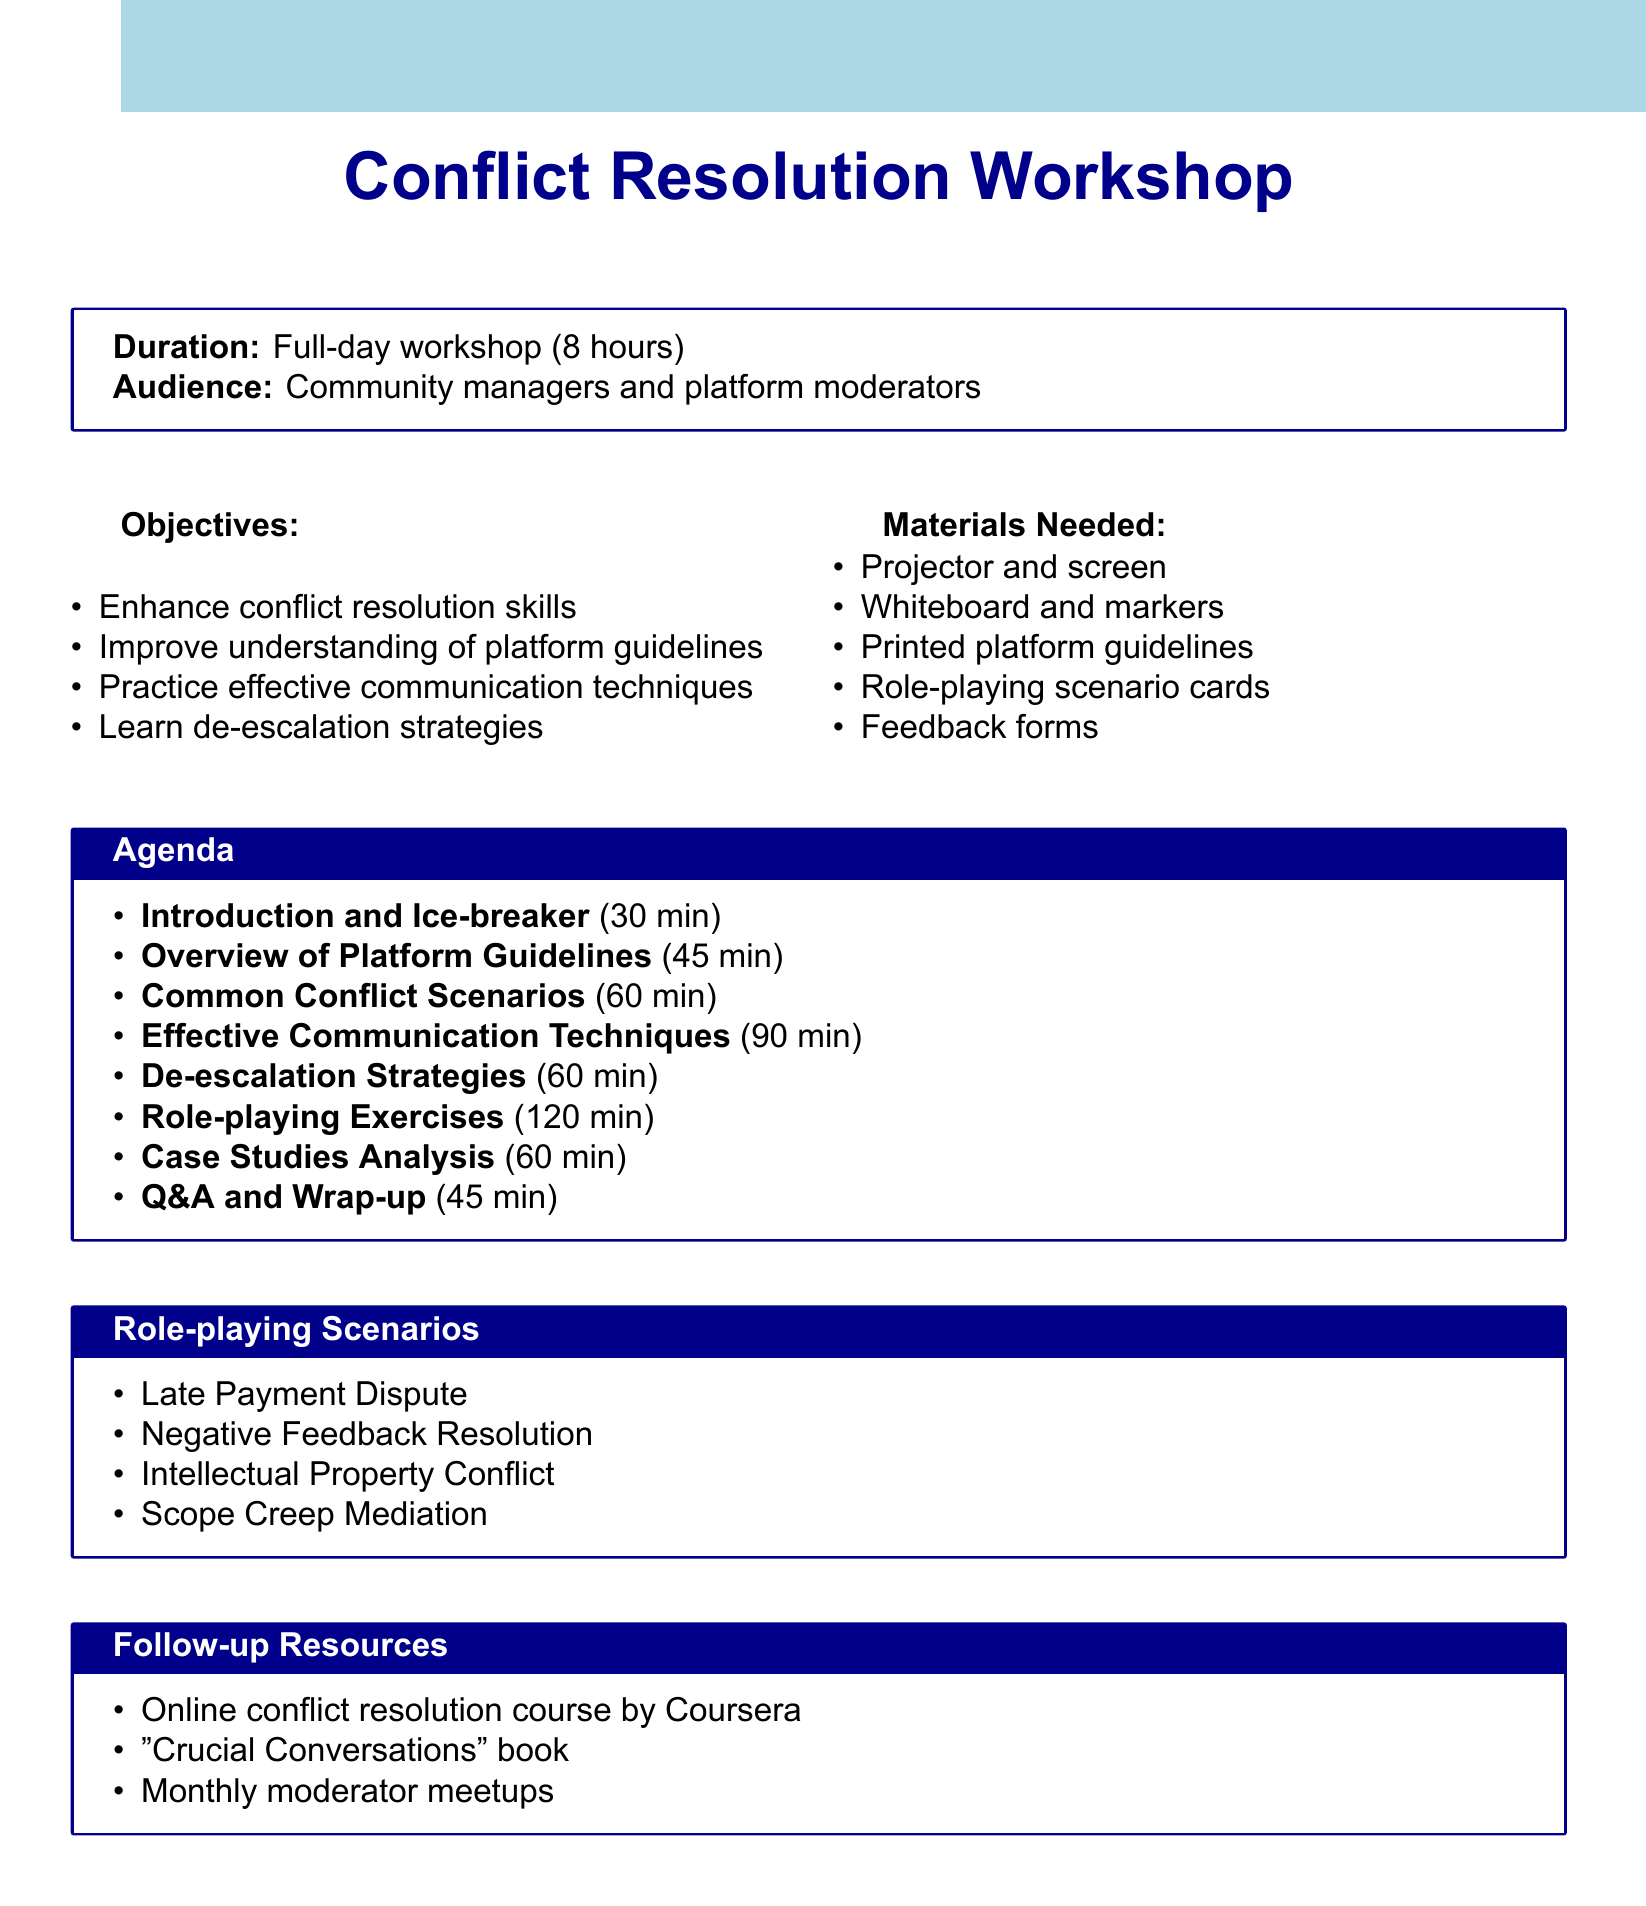what is the duration of the workshop? The duration of the workshop is stated clearly in the document.
Answer: Full-day workshop (8 hours) who is the target audience for the workshop? The audience is specified in the document as the participants intended for this workshop.
Answer: Community managers and platform moderators how long is the session on effective communication techniques? The duration of each agenda item is listed, making it easy to determine the length of this session.
Answer: 90 minutes what is one of the scenarios included in the role-playing exercises? The document includes a list of different scenarios used in role-playing, highlighting practical examples for participants.
Answer: Late Payment Dispute how many role-playing scenarios are mentioned in the document? The document lists the scenarios under role-playing exercises, allowing for easy counting of these specific items.
Answer: Four what is one follow-up resource provided after the workshop? The document mentions additional resources that can support learning after the workshop, making it straightforward to identify one.
Answer: Online conflict resolution course by Coursera what is the purpose of the "Case Studies Analysis" session? This agenda item gives insight into the focus of that particular session, which typically involves evaluation and discussion of real situations.
Answer: Examine real-life conflict resolution cases how many minutes is allocated for Q&A and wrap-up? The document specifies duration for each agenda item, making it easy to find the length for this specific part at the end of the workshop.
Answer: 45 minutes 